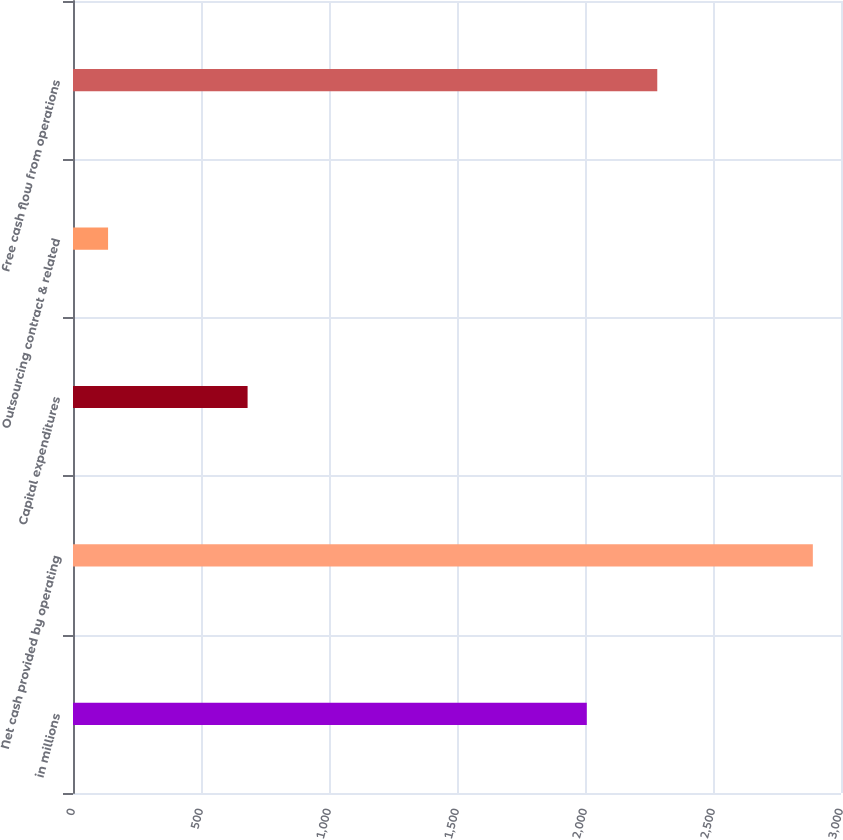Convert chart to OTSL. <chart><loc_0><loc_0><loc_500><loc_500><bar_chart><fcel>in millions<fcel>Net cash provided by operating<fcel>Capital expenditures<fcel>Outsourcing contract & related<fcel>Free cash flow from operations<nl><fcel>2007<fcel>2890<fcel>682<fcel>137<fcel>2282.3<nl></chart> 